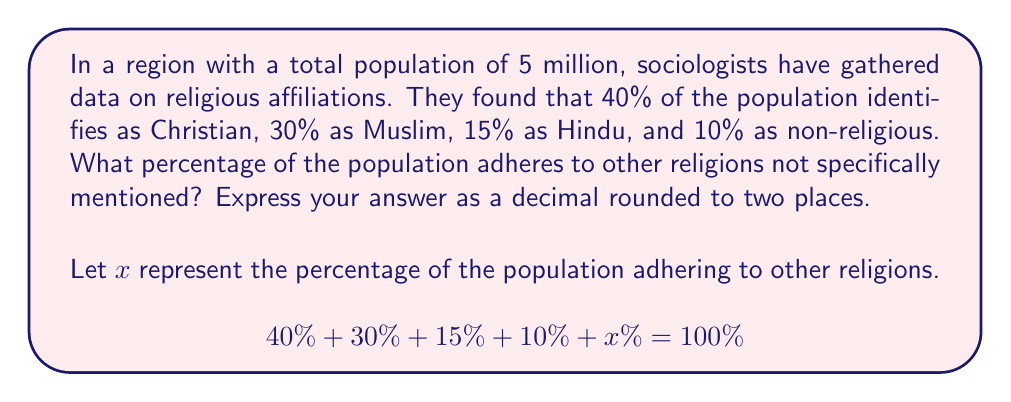Can you answer this question? To solve this problem, we'll follow these steps:

1. Convert the given percentages to decimals:
   40% = 0.40
   30% = 0.30
   15% = 0.15
   10% = 0.10

2. Set up the equation:
   $$0.40 + 0.30 + 0.15 + 0.10 + x = 1.00$$

   Note that we use 1.00 instead of 100% as we're working with decimals.

3. Add up the known percentages:
   $$0.40 + 0.30 + 0.15 + 0.10 = 0.95$$

4. Subtract the sum from 1.00 to find $x$:
   $$x = 1.00 - 0.95 = 0.05$$

5. Convert the result back to a percentage:
   $$0.05 = 5\%$$

This approach allows us to determine the percentage of the population adhering to other religions without making assumptions about specific belief systems, focusing solely on the demographic data.
Answer: 0.05 or 5% 